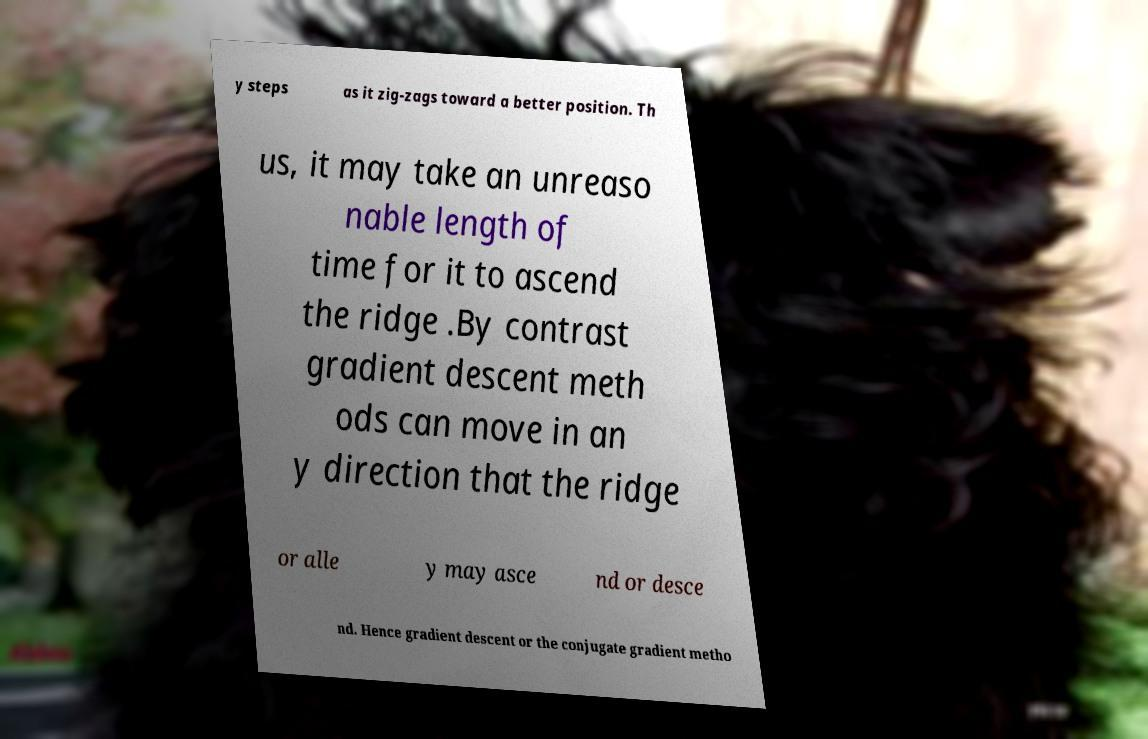Could you extract and type out the text from this image? y steps as it zig-zags toward a better position. Th us, it may take an unreaso nable length of time for it to ascend the ridge .By contrast gradient descent meth ods can move in an y direction that the ridge or alle y may asce nd or desce nd. Hence gradient descent or the conjugate gradient metho 